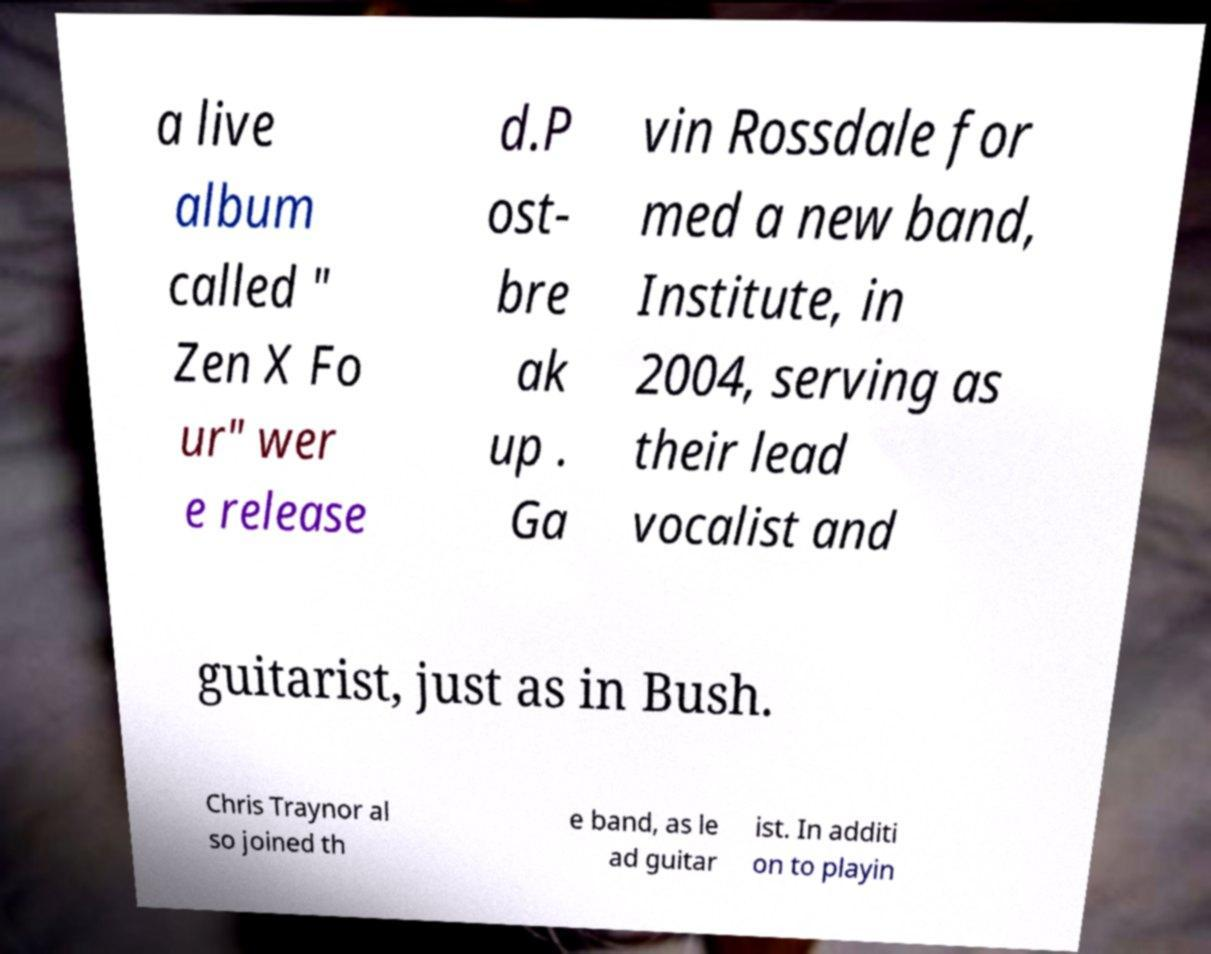Could you assist in decoding the text presented in this image and type it out clearly? a live album called " Zen X Fo ur" wer e release d.P ost- bre ak up . Ga vin Rossdale for med a new band, Institute, in 2004, serving as their lead vocalist and guitarist, just as in Bush. Chris Traynor al so joined th e band, as le ad guitar ist. In additi on to playin 